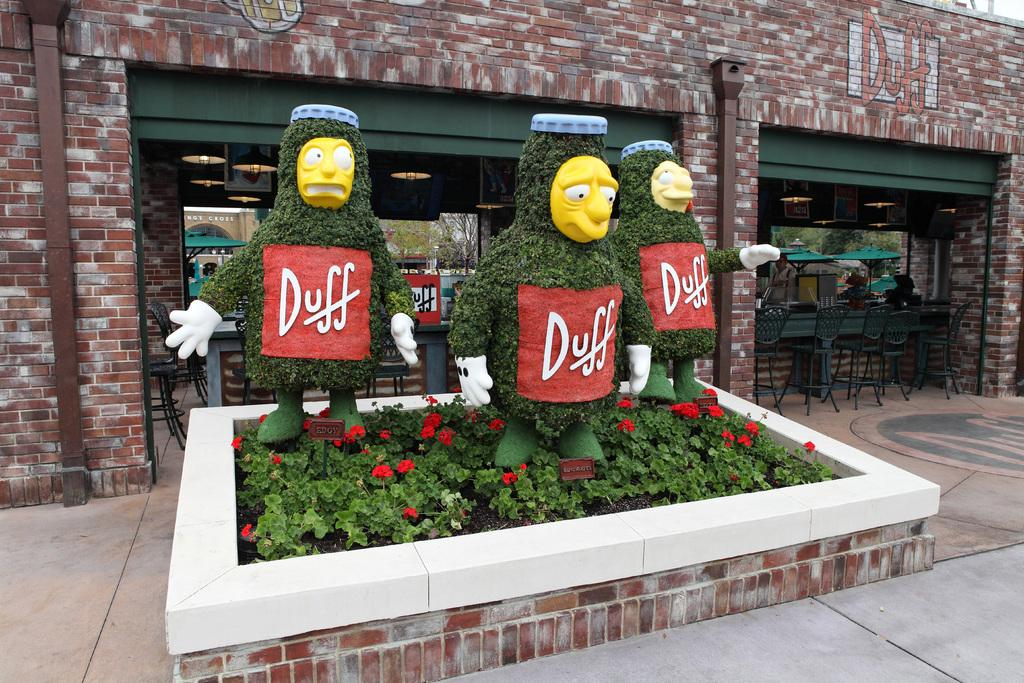Provide a one-sentence caption for the provided image. A small garden with hedges cut to look like Duff beer men from The Simpsons. 